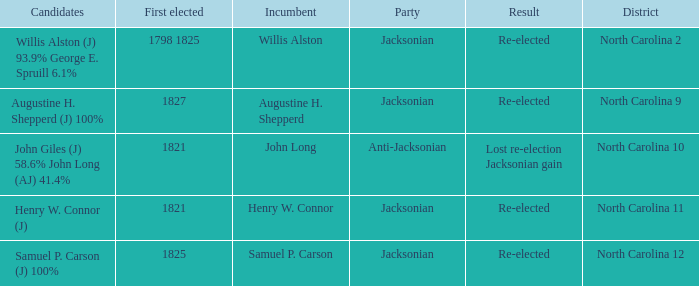Name the result for willis alston Re-elected. 